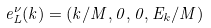<formula> <loc_0><loc_0><loc_500><loc_500>e _ { L } ^ { \nu } ( k ) = ( k / M , 0 , 0 , E _ { k } / M )</formula> 